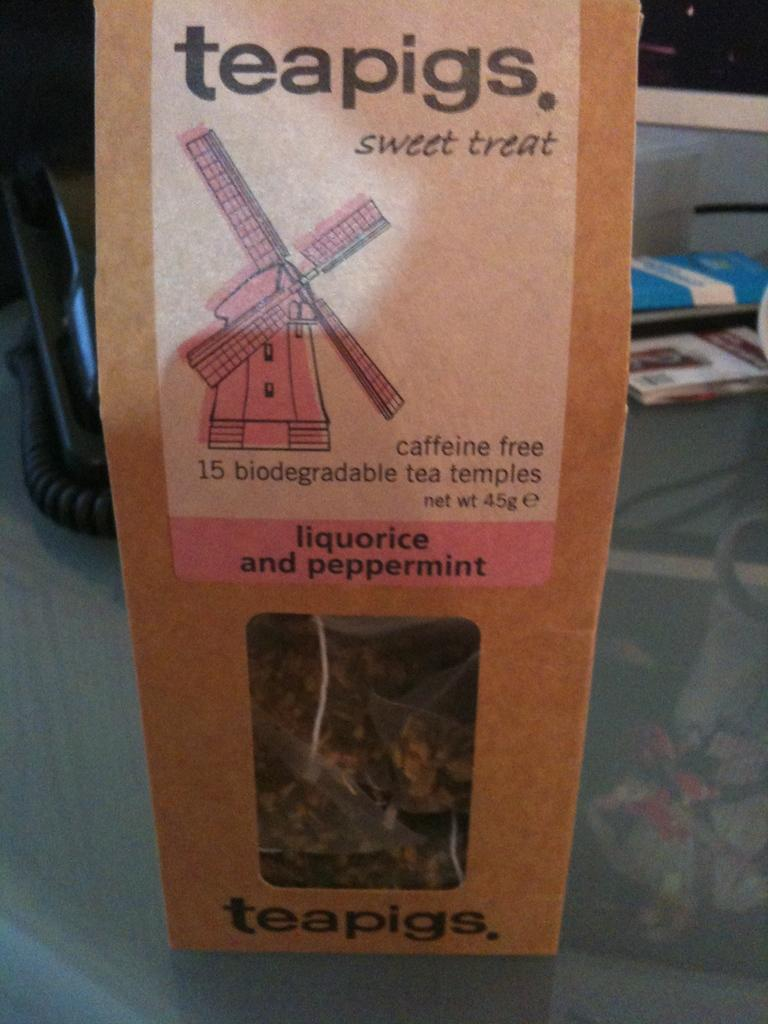<image>
Offer a succinct explanation of the picture presented. The type of treats shown are teapigs sweet treats 